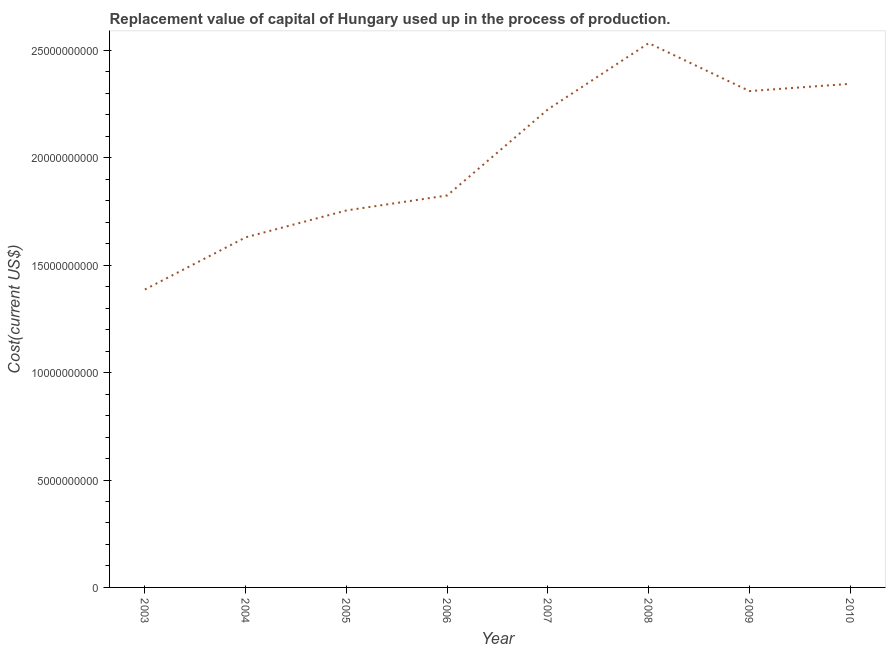What is the consumption of fixed capital in 2006?
Keep it short and to the point. 1.82e+1. Across all years, what is the maximum consumption of fixed capital?
Your response must be concise. 2.53e+1. Across all years, what is the minimum consumption of fixed capital?
Provide a short and direct response. 1.39e+1. In which year was the consumption of fixed capital maximum?
Provide a succinct answer. 2008. In which year was the consumption of fixed capital minimum?
Make the answer very short. 2003. What is the sum of the consumption of fixed capital?
Keep it short and to the point. 1.60e+11. What is the difference between the consumption of fixed capital in 2003 and 2006?
Ensure brevity in your answer.  -4.38e+09. What is the average consumption of fixed capital per year?
Make the answer very short. 2.00e+1. What is the median consumption of fixed capital?
Ensure brevity in your answer.  2.03e+1. Do a majority of the years between 2005 and 2007 (inclusive) have consumption of fixed capital greater than 11000000000 US$?
Provide a succinct answer. Yes. What is the ratio of the consumption of fixed capital in 2007 to that in 2008?
Keep it short and to the point. 0.88. Is the difference between the consumption of fixed capital in 2005 and 2009 greater than the difference between any two years?
Offer a very short reply. No. What is the difference between the highest and the second highest consumption of fixed capital?
Your response must be concise. 1.89e+09. What is the difference between the highest and the lowest consumption of fixed capital?
Your answer should be compact. 1.15e+1. Does the consumption of fixed capital monotonically increase over the years?
Your response must be concise. No. How many lines are there?
Make the answer very short. 1. How many years are there in the graph?
Your response must be concise. 8. What is the title of the graph?
Provide a succinct answer. Replacement value of capital of Hungary used up in the process of production. What is the label or title of the X-axis?
Offer a very short reply. Year. What is the label or title of the Y-axis?
Make the answer very short. Cost(current US$). What is the Cost(current US$) of 2003?
Make the answer very short. 1.39e+1. What is the Cost(current US$) in 2004?
Your answer should be compact. 1.63e+1. What is the Cost(current US$) of 2005?
Offer a very short reply. 1.75e+1. What is the Cost(current US$) in 2006?
Your response must be concise. 1.82e+1. What is the Cost(current US$) in 2007?
Your answer should be very brief. 2.23e+1. What is the Cost(current US$) of 2008?
Provide a succinct answer. 2.53e+1. What is the Cost(current US$) of 2009?
Offer a very short reply. 2.31e+1. What is the Cost(current US$) in 2010?
Give a very brief answer. 2.34e+1. What is the difference between the Cost(current US$) in 2003 and 2004?
Offer a very short reply. -2.43e+09. What is the difference between the Cost(current US$) in 2003 and 2005?
Keep it short and to the point. -3.68e+09. What is the difference between the Cost(current US$) in 2003 and 2006?
Give a very brief answer. -4.38e+09. What is the difference between the Cost(current US$) in 2003 and 2007?
Your answer should be compact. -8.39e+09. What is the difference between the Cost(current US$) in 2003 and 2008?
Your answer should be very brief. -1.15e+1. What is the difference between the Cost(current US$) in 2003 and 2009?
Offer a very short reply. -9.24e+09. What is the difference between the Cost(current US$) in 2003 and 2010?
Your answer should be very brief. -9.58e+09. What is the difference between the Cost(current US$) in 2004 and 2005?
Your answer should be very brief. -1.25e+09. What is the difference between the Cost(current US$) in 2004 and 2006?
Your answer should be compact. -1.95e+09. What is the difference between the Cost(current US$) in 2004 and 2007?
Offer a very short reply. -5.96e+09. What is the difference between the Cost(current US$) in 2004 and 2008?
Offer a very short reply. -9.04e+09. What is the difference between the Cost(current US$) in 2004 and 2009?
Your answer should be compact. -6.81e+09. What is the difference between the Cost(current US$) in 2004 and 2010?
Your answer should be very brief. -7.15e+09. What is the difference between the Cost(current US$) in 2005 and 2006?
Ensure brevity in your answer.  -6.97e+08. What is the difference between the Cost(current US$) in 2005 and 2007?
Your answer should be compact. -4.71e+09. What is the difference between the Cost(current US$) in 2005 and 2008?
Give a very brief answer. -7.79e+09. What is the difference between the Cost(current US$) in 2005 and 2009?
Offer a terse response. -5.56e+09. What is the difference between the Cost(current US$) in 2005 and 2010?
Offer a very short reply. -5.89e+09. What is the difference between the Cost(current US$) in 2006 and 2007?
Ensure brevity in your answer.  -4.01e+09. What is the difference between the Cost(current US$) in 2006 and 2008?
Offer a very short reply. -7.09e+09. What is the difference between the Cost(current US$) in 2006 and 2009?
Keep it short and to the point. -4.86e+09. What is the difference between the Cost(current US$) in 2006 and 2010?
Offer a very short reply. -5.20e+09. What is the difference between the Cost(current US$) in 2007 and 2008?
Keep it short and to the point. -3.08e+09. What is the difference between the Cost(current US$) in 2007 and 2009?
Provide a short and direct response. -8.51e+08. What is the difference between the Cost(current US$) in 2007 and 2010?
Your answer should be compact. -1.19e+09. What is the difference between the Cost(current US$) in 2008 and 2009?
Offer a terse response. 2.23e+09. What is the difference between the Cost(current US$) in 2008 and 2010?
Make the answer very short. 1.89e+09. What is the difference between the Cost(current US$) in 2009 and 2010?
Keep it short and to the point. -3.38e+08. What is the ratio of the Cost(current US$) in 2003 to that in 2004?
Provide a short and direct response. 0.85. What is the ratio of the Cost(current US$) in 2003 to that in 2005?
Provide a succinct answer. 0.79. What is the ratio of the Cost(current US$) in 2003 to that in 2006?
Keep it short and to the point. 0.76. What is the ratio of the Cost(current US$) in 2003 to that in 2007?
Offer a terse response. 0.62. What is the ratio of the Cost(current US$) in 2003 to that in 2008?
Your response must be concise. 0.55. What is the ratio of the Cost(current US$) in 2003 to that in 2009?
Provide a short and direct response. 0.6. What is the ratio of the Cost(current US$) in 2003 to that in 2010?
Provide a succinct answer. 0.59. What is the ratio of the Cost(current US$) in 2004 to that in 2005?
Provide a succinct answer. 0.93. What is the ratio of the Cost(current US$) in 2004 to that in 2006?
Provide a succinct answer. 0.89. What is the ratio of the Cost(current US$) in 2004 to that in 2007?
Your answer should be compact. 0.73. What is the ratio of the Cost(current US$) in 2004 to that in 2008?
Keep it short and to the point. 0.64. What is the ratio of the Cost(current US$) in 2004 to that in 2009?
Your response must be concise. 0.7. What is the ratio of the Cost(current US$) in 2004 to that in 2010?
Give a very brief answer. 0.69. What is the ratio of the Cost(current US$) in 2005 to that in 2007?
Your answer should be compact. 0.79. What is the ratio of the Cost(current US$) in 2005 to that in 2008?
Your answer should be very brief. 0.69. What is the ratio of the Cost(current US$) in 2005 to that in 2009?
Make the answer very short. 0.76. What is the ratio of the Cost(current US$) in 2005 to that in 2010?
Offer a terse response. 0.75. What is the ratio of the Cost(current US$) in 2006 to that in 2007?
Provide a succinct answer. 0.82. What is the ratio of the Cost(current US$) in 2006 to that in 2008?
Ensure brevity in your answer.  0.72. What is the ratio of the Cost(current US$) in 2006 to that in 2009?
Provide a short and direct response. 0.79. What is the ratio of the Cost(current US$) in 2006 to that in 2010?
Provide a short and direct response. 0.78. What is the ratio of the Cost(current US$) in 2007 to that in 2008?
Give a very brief answer. 0.88. What is the ratio of the Cost(current US$) in 2007 to that in 2009?
Provide a succinct answer. 0.96. What is the ratio of the Cost(current US$) in 2007 to that in 2010?
Provide a succinct answer. 0.95. What is the ratio of the Cost(current US$) in 2008 to that in 2009?
Ensure brevity in your answer.  1.1. What is the ratio of the Cost(current US$) in 2008 to that in 2010?
Provide a short and direct response. 1.08. What is the ratio of the Cost(current US$) in 2009 to that in 2010?
Offer a terse response. 0.99. 